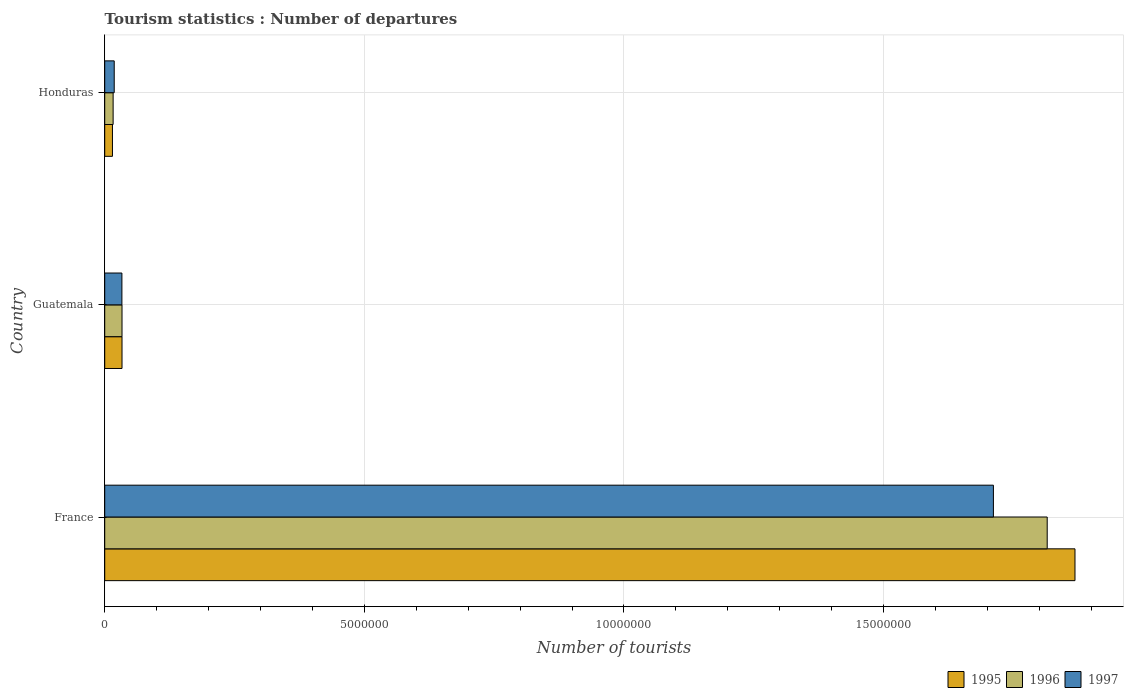How many different coloured bars are there?
Provide a short and direct response. 3. How many groups of bars are there?
Your answer should be very brief. 3. Are the number of bars per tick equal to the number of legend labels?
Your answer should be compact. Yes. Are the number of bars on each tick of the Y-axis equal?
Give a very brief answer. Yes. What is the number of tourist departures in 1995 in France?
Make the answer very short. 1.87e+07. Across all countries, what is the maximum number of tourist departures in 1996?
Provide a short and direct response. 1.82e+07. Across all countries, what is the minimum number of tourist departures in 1997?
Give a very brief answer. 1.83e+05. In which country was the number of tourist departures in 1997 maximum?
Offer a terse response. France. In which country was the number of tourist departures in 1997 minimum?
Your answer should be very brief. Honduras. What is the total number of tourist departures in 1996 in the graph?
Offer a very short reply. 1.86e+07. What is the difference between the number of tourist departures in 1995 in France and that in Guatemala?
Provide a short and direct response. 1.84e+07. What is the difference between the number of tourist departures in 1996 in Guatemala and the number of tourist departures in 1995 in France?
Your response must be concise. -1.84e+07. What is the average number of tourist departures in 1995 per country?
Your response must be concise. 6.39e+06. What is the difference between the number of tourist departures in 1997 and number of tourist departures in 1996 in France?
Provide a succinct answer. -1.04e+06. In how many countries, is the number of tourist departures in 1997 greater than 4000000 ?
Offer a terse response. 1. What is the ratio of the number of tourist departures in 1996 in Guatemala to that in Honduras?
Offer a very short reply. 2.06. Is the number of tourist departures in 1997 in Guatemala less than that in Honduras?
Provide a succinct answer. No. Is the difference between the number of tourist departures in 1997 in France and Honduras greater than the difference between the number of tourist departures in 1996 in France and Honduras?
Make the answer very short. No. What is the difference between the highest and the second highest number of tourist departures in 1996?
Offer a very short reply. 1.78e+07. What is the difference between the highest and the lowest number of tourist departures in 1997?
Your response must be concise. 1.69e+07. Is the sum of the number of tourist departures in 1997 in France and Guatemala greater than the maximum number of tourist departures in 1995 across all countries?
Provide a succinct answer. No. What does the 3rd bar from the top in Honduras represents?
Your answer should be compact. 1995. What does the 3rd bar from the bottom in France represents?
Give a very brief answer. 1997. How many bars are there?
Provide a succinct answer. 9. Are all the bars in the graph horizontal?
Make the answer very short. Yes. Does the graph contain grids?
Provide a succinct answer. Yes. How many legend labels are there?
Keep it short and to the point. 3. What is the title of the graph?
Your response must be concise. Tourism statistics : Number of departures. Does "2005" appear as one of the legend labels in the graph?
Provide a succinct answer. No. What is the label or title of the X-axis?
Your answer should be compact. Number of tourists. What is the Number of tourists in 1995 in France?
Keep it short and to the point. 1.87e+07. What is the Number of tourists in 1996 in France?
Offer a terse response. 1.82e+07. What is the Number of tourists in 1997 in France?
Keep it short and to the point. 1.71e+07. What is the Number of tourists of 1995 in Guatemala?
Offer a very short reply. 3.33e+05. What is the Number of tourists in 1996 in Guatemala?
Keep it short and to the point. 3.33e+05. What is the Number of tourists in 1997 in Guatemala?
Ensure brevity in your answer.  3.31e+05. What is the Number of tourists of 1995 in Honduras?
Your answer should be very brief. 1.49e+05. What is the Number of tourists of 1996 in Honduras?
Provide a short and direct response. 1.62e+05. What is the Number of tourists of 1997 in Honduras?
Offer a terse response. 1.83e+05. Across all countries, what is the maximum Number of tourists of 1995?
Your answer should be compact. 1.87e+07. Across all countries, what is the maximum Number of tourists of 1996?
Offer a very short reply. 1.82e+07. Across all countries, what is the maximum Number of tourists in 1997?
Keep it short and to the point. 1.71e+07. Across all countries, what is the minimum Number of tourists in 1995?
Ensure brevity in your answer.  1.49e+05. Across all countries, what is the minimum Number of tourists in 1996?
Offer a terse response. 1.62e+05. Across all countries, what is the minimum Number of tourists of 1997?
Provide a succinct answer. 1.83e+05. What is the total Number of tourists of 1995 in the graph?
Offer a very short reply. 1.92e+07. What is the total Number of tourists in 1996 in the graph?
Keep it short and to the point. 1.86e+07. What is the total Number of tourists of 1997 in the graph?
Offer a terse response. 1.76e+07. What is the difference between the Number of tourists in 1995 in France and that in Guatemala?
Provide a succinct answer. 1.84e+07. What is the difference between the Number of tourists in 1996 in France and that in Guatemala?
Offer a terse response. 1.78e+07. What is the difference between the Number of tourists in 1997 in France and that in Guatemala?
Ensure brevity in your answer.  1.68e+07. What is the difference between the Number of tourists in 1995 in France and that in Honduras?
Your answer should be compact. 1.85e+07. What is the difference between the Number of tourists of 1996 in France and that in Honduras?
Your answer should be very brief. 1.80e+07. What is the difference between the Number of tourists in 1997 in France and that in Honduras?
Make the answer very short. 1.69e+07. What is the difference between the Number of tourists of 1995 in Guatemala and that in Honduras?
Offer a terse response. 1.84e+05. What is the difference between the Number of tourists in 1996 in Guatemala and that in Honduras?
Your answer should be very brief. 1.71e+05. What is the difference between the Number of tourists of 1997 in Guatemala and that in Honduras?
Your response must be concise. 1.48e+05. What is the difference between the Number of tourists of 1995 in France and the Number of tourists of 1996 in Guatemala?
Keep it short and to the point. 1.84e+07. What is the difference between the Number of tourists of 1995 in France and the Number of tourists of 1997 in Guatemala?
Provide a succinct answer. 1.84e+07. What is the difference between the Number of tourists in 1996 in France and the Number of tourists in 1997 in Guatemala?
Offer a terse response. 1.78e+07. What is the difference between the Number of tourists of 1995 in France and the Number of tourists of 1996 in Honduras?
Ensure brevity in your answer.  1.85e+07. What is the difference between the Number of tourists of 1995 in France and the Number of tourists of 1997 in Honduras?
Provide a short and direct response. 1.85e+07. What is the difference between the Number of tourists of 1996 in France and the Number of tourists of 1997 in Honduras?
Your answer should be very brief. 1.80e+07. What is the difference between the Number of tourists of 1995 in Guatemala and the Number of tourists of 1996 in Honduras?
Your response must be concise. 1.71e+05. What is the average Number of tourists of 1995 per country?
Offer a very short reply. 6.39e+06. What is the average Number of tourists of 1996 per country?
Ensure brevity in your answer.  6.22e+06. What is the average Number of tourists of 1997 per country?
Offer a terse response. 5.88e+06. What is the difference between the Number of tourists in 1995 and Number of tourists in 1996 in France?
Provide a short and direct response. 5.35e+05. What is the difference between the Number of tourists in 1995 and Number of tourists in 1997 in France?
Offer a very short reply. 1.57e+06. What is the difference between the Number of tourists in 1996 and Number of tourists in 1997 in France?
Offer a very short reply. 1.04e+06. What is the difference between the Number of tourists in 1995 and Number of tourists in 1997 in Guatemala?
Make the answer very short. 2000. What is the difference between the Number of tourists in 1996 and Number of tourists in 1997 in Guatemala?
Your answer should be compact. 2000. What is the difference between the Number of tourists of 1995 and Number of tourists of 1996 in Honduras?
Ensure brevity in your answer.  -1.30e+04. What is the difference between the Number of tourists of 1995 and Number of tourists of 1997 in Honduras?
Ensure brevity in your answer.  -3.40e+04. What is the difference between the Number of tourists of 1996 and Number of tourists of 1997 in Honduras?
Your answer should be compact. -2.10e+04. What is the ratio of the Number of tourists in 1995 in France to that in Guatemala?
Keep it short and to the point. 56.11. What is the ratio of the Number of tourists of 1996 in France to that in Guatemala?
Offer a terse response. 54.51. What is the ratio of the Number of tourists in 1997 in France to that in Guatemala?
Offer a very short reply. 51.71. What is the ratio of the Number of tourists in 1995 in France to that in Honduras?
Your answer should be very brief. 125.41. What is the ratio of the Number of tourists of 1996 in France to that in Honduras?
Your response must be concise. 112.04. What is the ratio of the Number of tourists in 1997 in France to that in Honduras?
Give a very brief answer. 93.52. What is the ratio of the Number of tourists in 1995 in Guatemala to that in Honduras?
Provide a succinct answer. 2.23. What is the ratio of the Number of tourists in 1996 in Guatemala to that in Honduras?
Keep it short and to the point. 2.06. What is the ratio of the Number of tourists of 1997 in Guatemala to that in Honduras?
Offer a terse response. 1.81. What is the difference between the highest and the second highest Number of tourists in 1995?
Offer a terse response. 1.84e+07. What is the difference between the highest and the second highest Number of tourists in 1996?
Your answer should be very brief. 1.78e+07. What is the difference between the highest and the second highest Number of tourists in 1997?
Provide a succinct answer. 1.68e+07. What is the difference between the highest and the lowest Number of tourists in 1995?
Provide a short and direct response. 1.85e+07. What is the difference between the highest and the lowest Number of tourists of 1996?
Ensure brevity in your answer.  1.80e+07. What is the difference between the highest and the lowest Number of tourists in 1997?
Ensure brevity in your answer.  1.69e+07. 